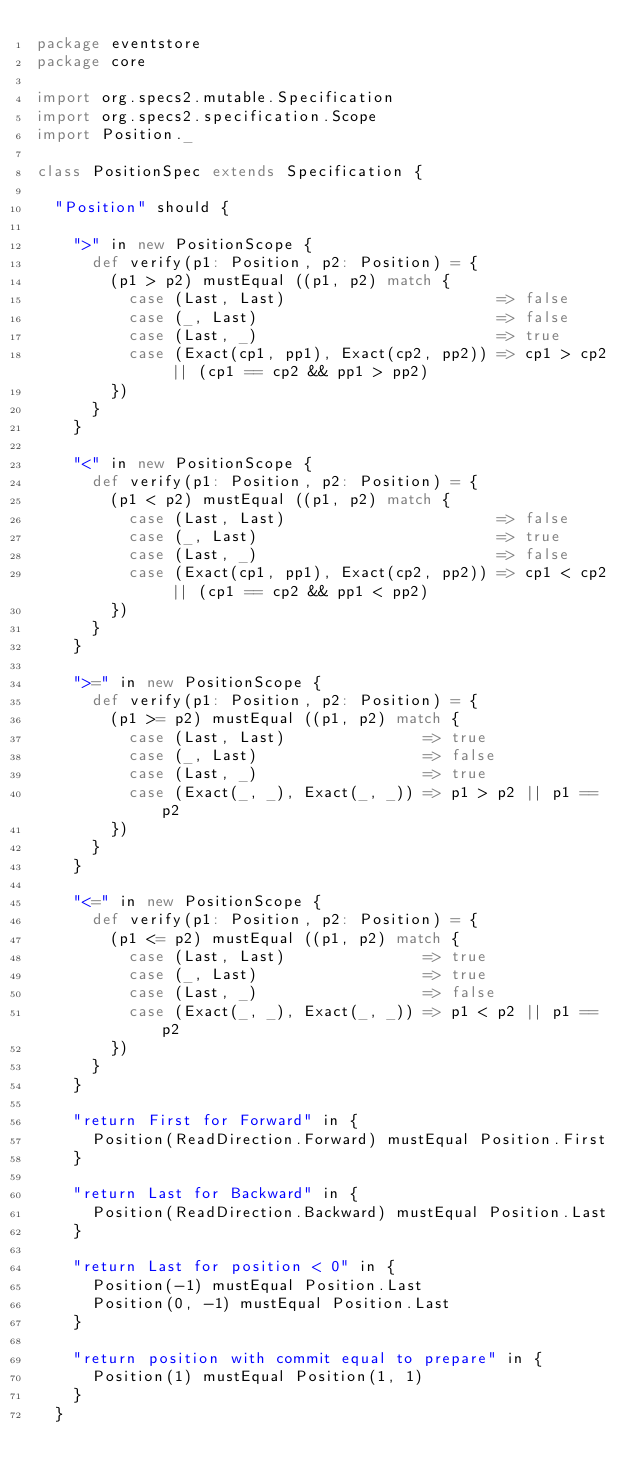<code> <loc_0><loc_0><loc_500><loc_500><_Scala_>package eventstore
package core

import org.specs2.mutable.Specification
import org.specs2.specification.Scope
import Position._

class PositionSpec extends Specification {

  "Position" should {

    ">" in new PositionScope {
      def verify(p1: Position, p2: Position) = {
        (p1 > p2) mustEqual ((p1, p2) match {
          case (Last, Last)                       => false
          case (_, Last)                          => false
          case (Last, _)                          => true
          case (Exact(cp1, pp1), Exact(cp2, pp2)) => cp1 > cp2 || (cp1 == cp2 && pp1 > pp2)
        })
      }
    }

    "<" in new PositionScope {
      def verify(p1: Position, p2: Position) = {
        (p1 < p2) mustEqual ((p1, p2) match {
          case (Last, Last)                       => false
          case (_, Last)                          => true
          case (Last, _)                          => false
          case (Exact(cp1, pp1), Exact(cp2, pp2)) => cp1 < cp2 || (cp1 == cp2 && pp1 < pp2)
        })
      }
    }

    ">=" in new PositionScope {
      def verify(p1: Position, p2: Position) = {
        (p1 >= p2) mustEqual ((p1, p2) match {
          case (Last, Last)               => true
          case (_, Last)                  => false
          case (Last, _)                  => true
          case (Exact(_, _), Exact(_, _)) => p1 > p2 || p1 == p2
        })
      }
    }

    "<=" in new PositionScope {
      def verify(p1: Position, p2: Position) = {
        (p1 <= p2) mustEqual ((p1, p2) match {
          case (Last, Last)               => true
          case (_, Last)                  => true
          case (Last, _)                  => false
          case (Exact(_, _), Exact(_, _)) => p1 < p2 || p1 == p2
        })
      }
    }

    "return First for Forward" in {
      Position(ReadDirection.Forward) mustEqual Position.First
    }

    "return Last for Backward" in {
      Position(ReadDirection.Backward) mustEqual Position.Last
    }

    "return Last for position < 0" in {
      Position(-1) mustEqual Position.Last
      Position(0, -1) mustEqual Position.Last
    }

    "return position with commit equal to prepare" in {
      Position(1) mustEqual Position(1, 1)
    }
  }
</code> 